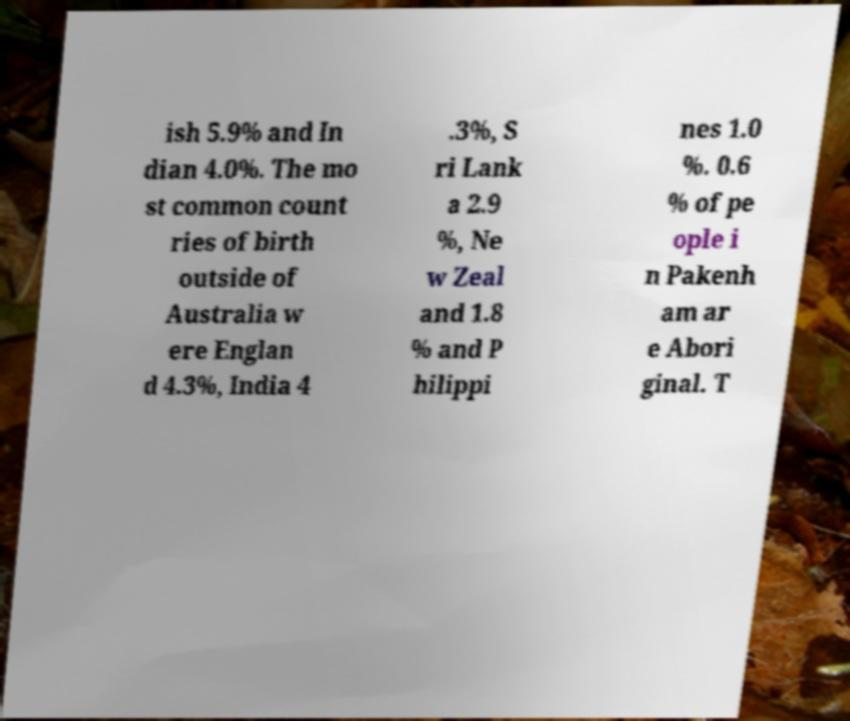Could you assist in decoding the text presented in this image and type it out clearly? ish 5.9% and In dian 4.0%. The mo st common count ries of birth outside of Australia w ere Englan d 4.3%, India 4 .3%, S ri Lank a 2.9 %, Ne w Zeal and 1.8 % and P hilippi nes 1.0 %. 0.6 % of pe ople i n Pakenh am ar e Abori ginal. T 